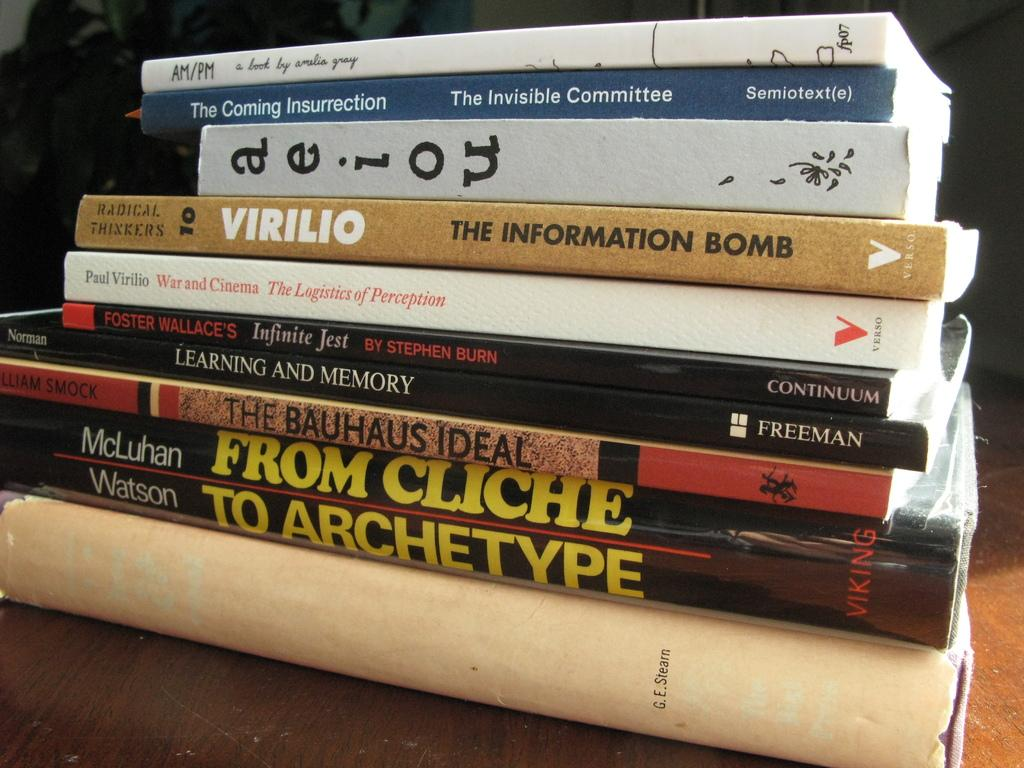<image>
Describe the image concisely. A stack of books one is called the information bomb. 